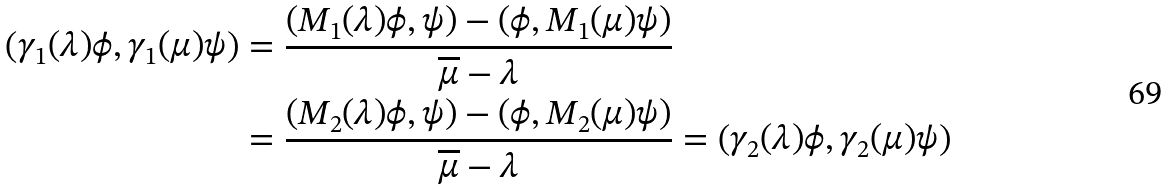Convert formula to latex. <formula><loc_0><loc_0><loc_500><loc_500>\left ( \gamma _ { 1 } ( \lambda ) \phi , \gamma _ { 1 } ( \mu ) \psi \right ) & = \frac { ( M _ { 1 } ( \lambda ) \phi , \psi ) - ( \phi , M _ { 1 } ( \mu ) \psi ) } { \overline { \mu } - \lambda } \\ & = \frac { ( M _ { 2 } ( \lambda ) \phi , \psi ) - ( \phi , M _ { 2 } ( \mu ) \psi ) } { \overline { \mu } - \lambda } = \left ( \gamma _ { 2 } ( \lambda ) \phi , \gamma _ { 2 } ( \mu ) \psi \right )</formula> 